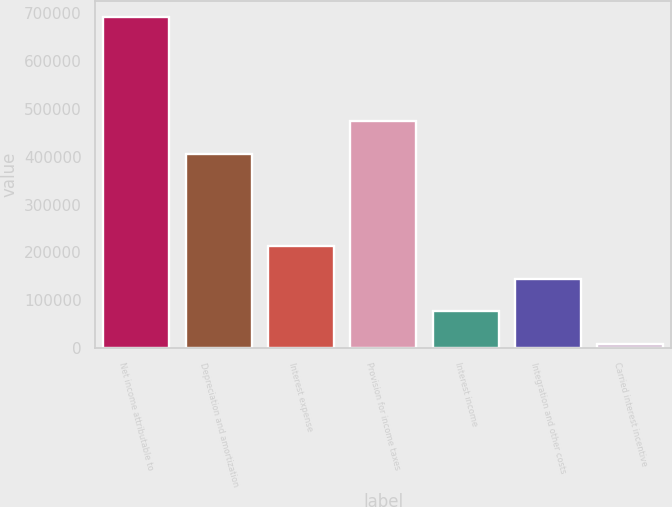Convert chart. <chart><loc_0><loc_0><loc_500><loc_500><bar_chart><fcel>Net income attributable to<fcel>Depreciation and amortization<fcel>Interest expense<fcel>Provision for income taxes<fcel>Interest income<fcel>Integration and other costs<fcel>Carried interest incentive<nl><fcel>691479<fcel>406114<fcel>213406<fcel>474410<fcel>76814.1<fcel>145110<fcel>8518<nl></chart> 